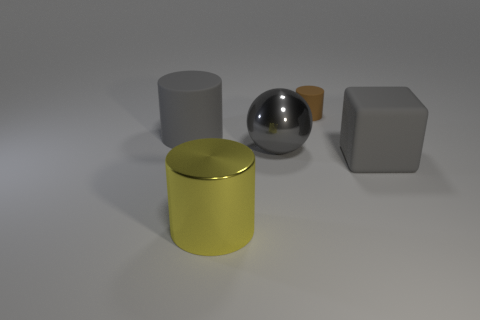Add 3 tiny brown rubber cylinders. How many objects exist? 8 Subtract all large cylinders. How many cylinders are left? 1 Subtract all yellow cylinders. Subtract all red spheres. How many cylinders are left? 2 Subtract all yellow blocks. How many red spheres are left? 0 Subtract all small matte cylinders. Subtract all metallic cylinders. How many objects are left? 3 Add 4 big gray cylinders. How many big gray cylinders are left? 5 Add 1 matte cylinders. How many matte cylinders exist? 3 Subtract 0 purple cylinders. How many objects are left? 5 Subtract all blocks. How many objects are left? 4 Subtract 1 balls. How many balls are left? 0 